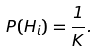Convert formula to latex. <formula><loc_0><loc_0><loc_500><loc_500>P ( H _ { i } ) = \frac { 1 } { K } .</formula> 